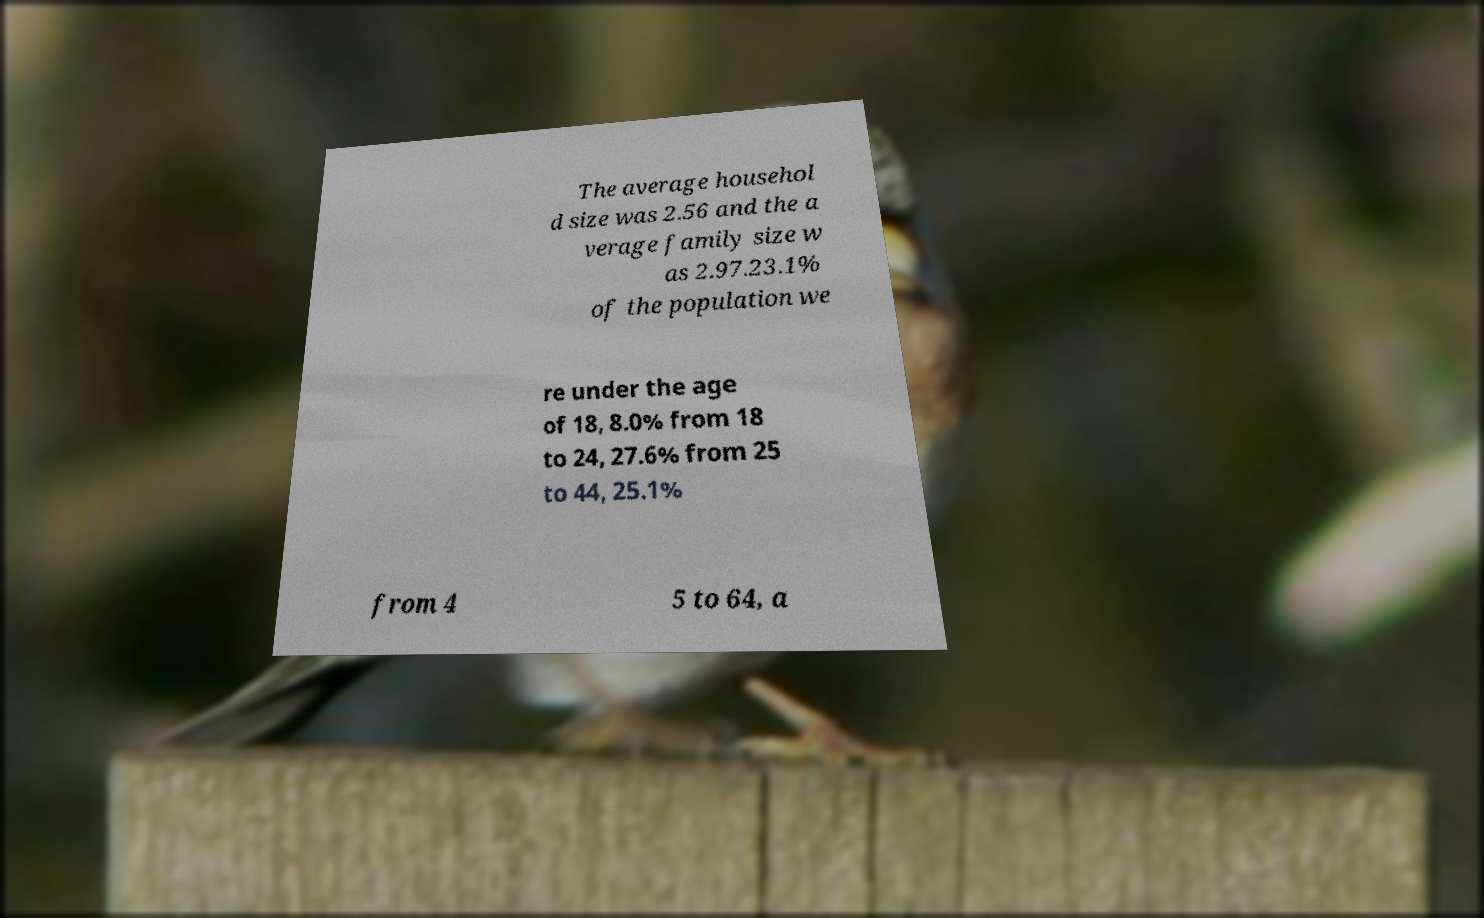Please read and relay the text visible in this image. What does it say? The average househol d size was 2.56 and the a verage family size w as 2.97.23.1% of the population we re under the age of 18, 8.0% from 18 to 24, 27.6% from 25 to 44, 25.1% from 4 5 to 64, a 